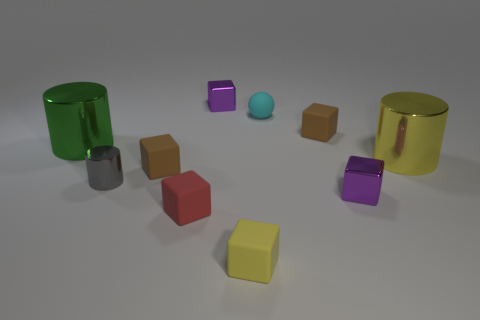Subtract all yellow metal cylinders. How many cylinders are left? 2 Subtract all red balls. How many brown cubes are left? 2 Subtract 1 cylinders. How many cylinders are left? 2 Subtract all yellow cylinders. How many cylinders are left? 2 Subtract all cylinders. How many objects are left? 7 Add 2 yellow rubber things. How many yellow rubber things exist? 3 Subtract 0 blue cylinders. How many objects are left? 10 Subtract all yellow cubes. Subtract all cyan cylinders. How many cubes are left? 5 Subtract all small metallic objects. Subtract all shiny objects. How many objects are left? 2 Add 6 red rubber blocks. How many red rubber blocks are left? 7 